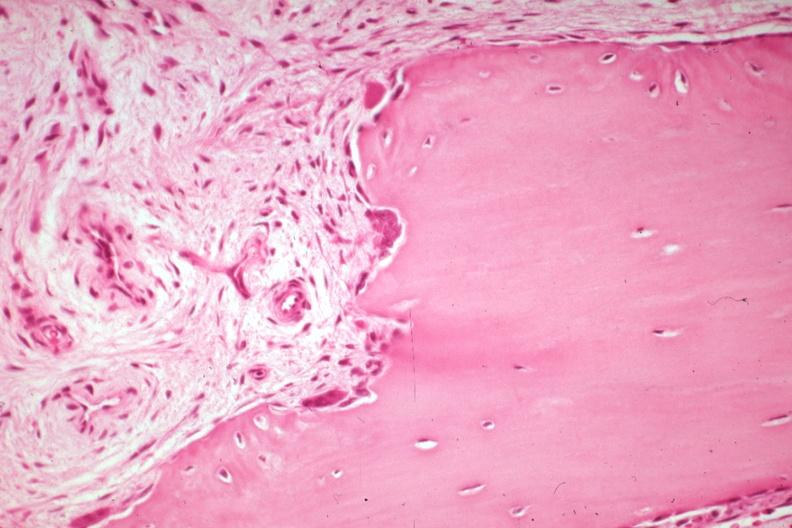what is present?
Answer the question using a single word or phrase. Joints 